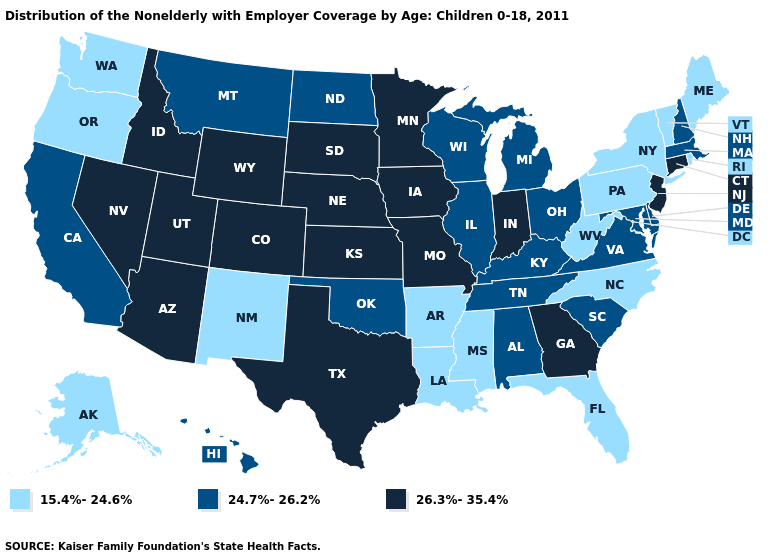Among the states that border Oklahoma , which have the lowest value?
Keep it brief. Arkansas, New Mexico. What is the highest value in the South ?
Quick response, please. 26.3%-35.4%. Which states hav the highest value in the South?
Give a very brief answer. Georgia, Texas. What is the value of Oregon?
Keep it brief. 15.4%-24.6%. How many symbols are there in the legend?
Short answer required. 3. Name the states that have a value in the range 24.7%-26.2%?
Concise answer only. Alabama, California, Delaware, Hawaii, Illinois, Kentucky, Maryland, Massachusetts, Michigan, Montana, New Hampshire, North Dakota, Ohio, Oklahoma, South Carolina, Tennessee, Virginia, Wisconsin. Which states have the highest value in the USA?
Be succinct. Arizona, Colorado, Connecticut, Georgia, Idaho, Indiana, Iowa, Kansas, Minnesota, Missouri, Nebraska, Nevada, New Jersey, South Dakota, Texas, Utah, Wyoming. What is the value of Utah?
Quick response, please. 26.3%-35.4%. Name the states that have a value in the range 24.7%-26.2%?
Be succinct. Alabama, California, Delaware, Hawaii, Illinois, Kentucky, Maryland, Massachusetts, Michigan, Montana, New Hampshire, North Dakota, Ohio, Oklahoma, South Carolina, Tennessee, Virginia, Wisconsin. Which states hav the highest value in the MidWest?
Answer briefly. Indiana, Iowa, Kansas, Minnesota, Missouri, Nebraska, South Dakota. Name the states that have a value in the range 24.7%-26.2%?
Be succinct. Alabama, California, Delaware, Hawaii, Illinois, Kentucky, Maryland, Massachusetts, Michigan, Montana, New Hampshire, North Dakota, Ohio, Oklahoma, South Carolina, Tennessee, Virginia, Wisconsin. What is the value of North Carolina?
Answer briefly. 15.4%-24.6%. Does Rhode Island have the same value as Connecticut?
Keep it brief. No. Among the states that border Mississippi , does Tennessee have the lowest value?
Short answer required. No. 